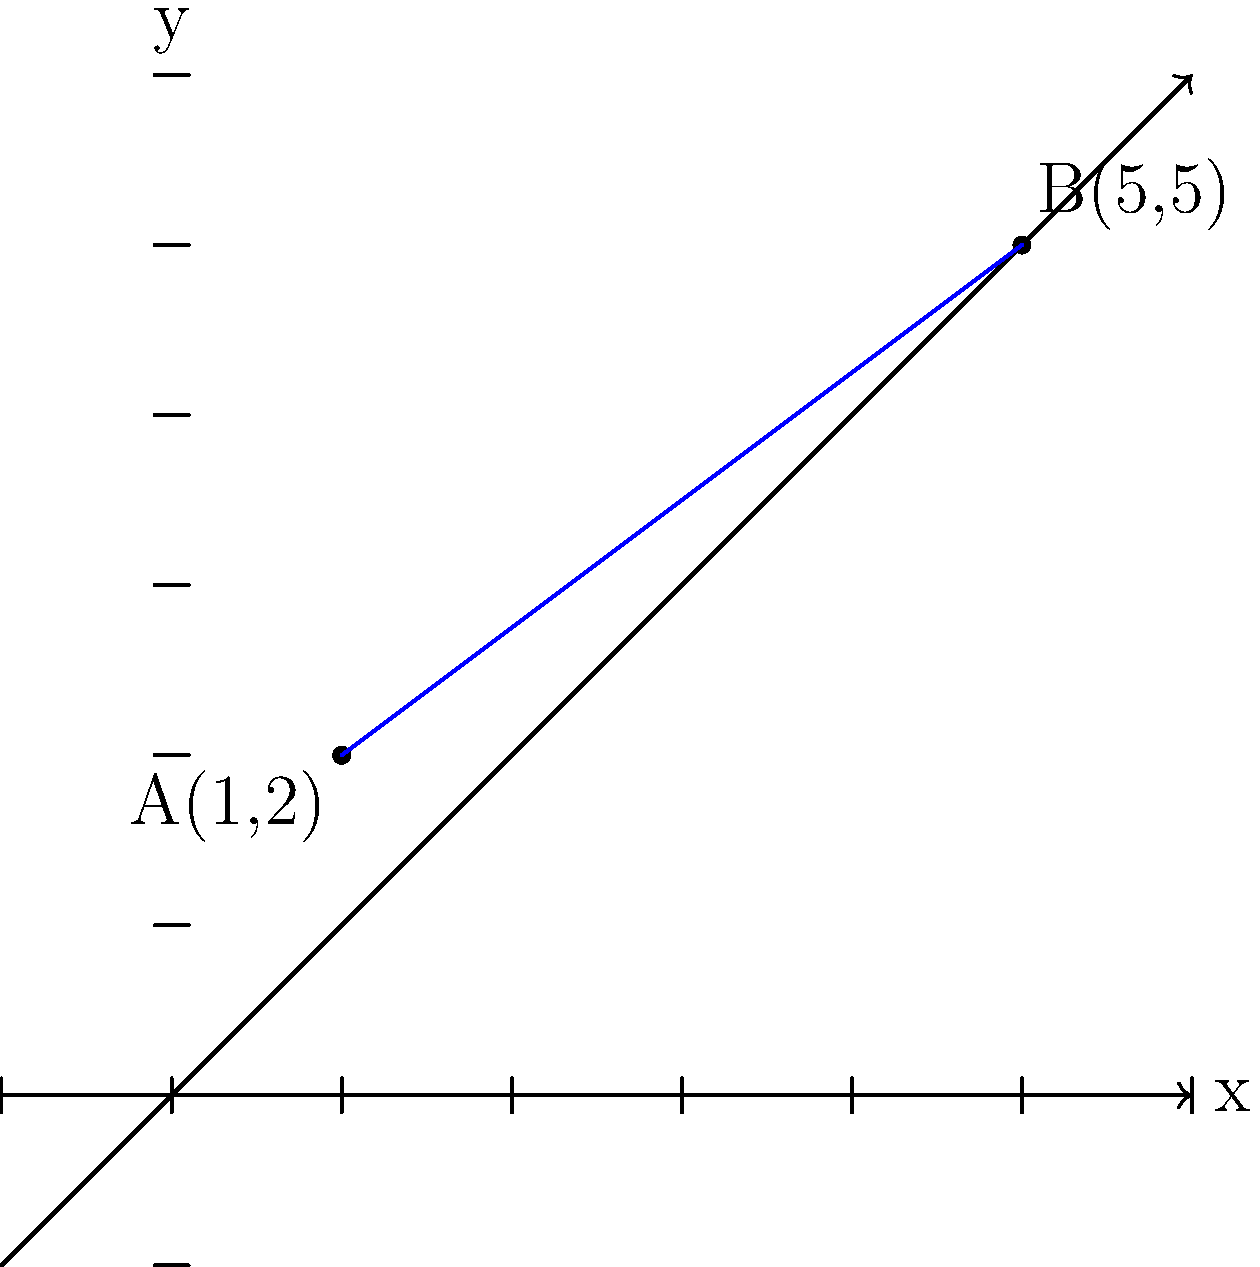As a senior iOS developer guiding a junior developer, you want to explain how to calculate the distance between two points on a coordinate plane. Consider points A(1,2) and B(5,5) on the given coordinate plane. Calculate the distance between these two points using the distance formula. To find the distance between two points on a coordinate plane, we use the distance formula, which is derived from the Pythagorean theorem. Let's go through this step-by-step:

1) The distance formula is:
   $$d = \sqrt{(x_2 - x_1)^2 + (y_2 - y_1)^2}$$
   where $(x_1, y_1)$ are the coordinates of the first point and $(x_2, y_2)$ are the coordinates of the second point.

2) In our case:
   Point A: $(x_1, y_1) = (1, 2)$
   Point B: $(x_2, y_2) = (5, 5)$

3) Let's substitute these values into the formula:
   $$d = \sqrt{(5 - 1)^2 + (5 - 2)^2}$$

4) Simplify the expressions inside the parentheses:
   $$d = \sqrt{4^2 + 3^2}$$

5) Calculate the squares:
   $$d = \sqrt{16 + 9}$$

6) Add the numbers under the square root:
   $$d = \sqrt{25}$$

7) Simplify the square root:
   $$d = 5$$

Therefore, the distance between points A(1,2) and B(5,5) is 5 units.
Answer: 5 units 